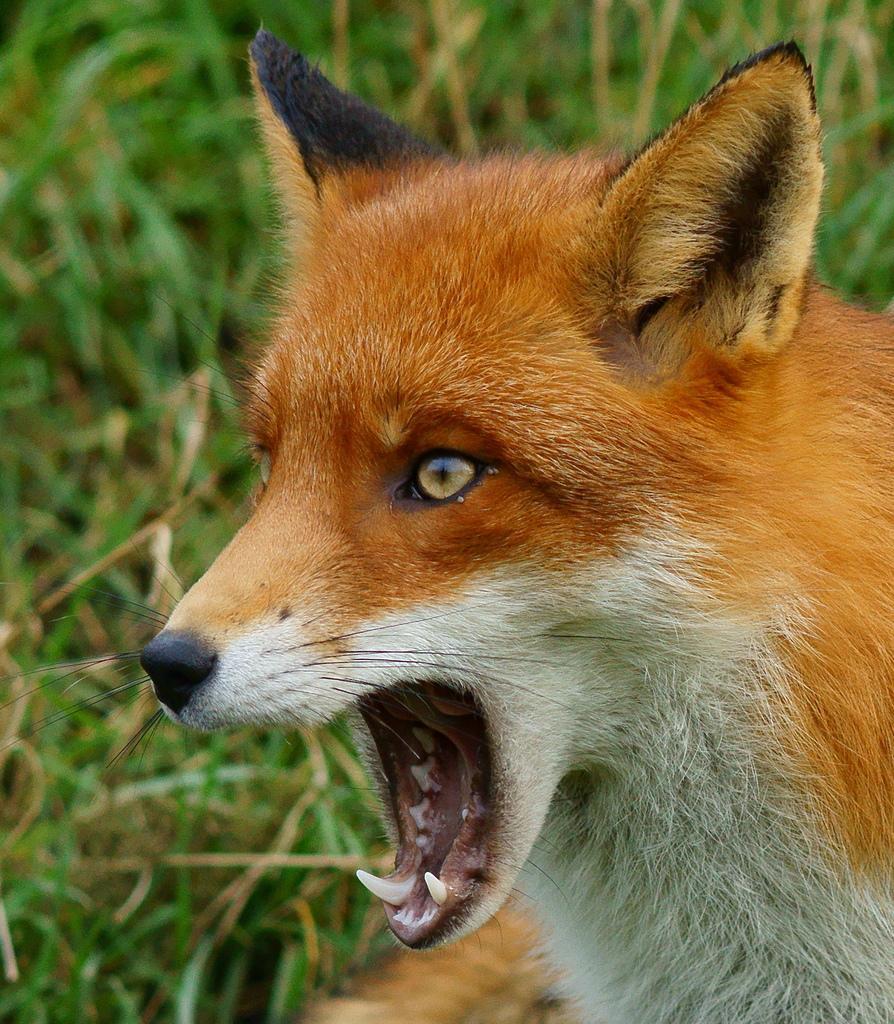Can you describe this image briefly? In this picture there is an animal and it is in white and orange color. At the back there is grass. 